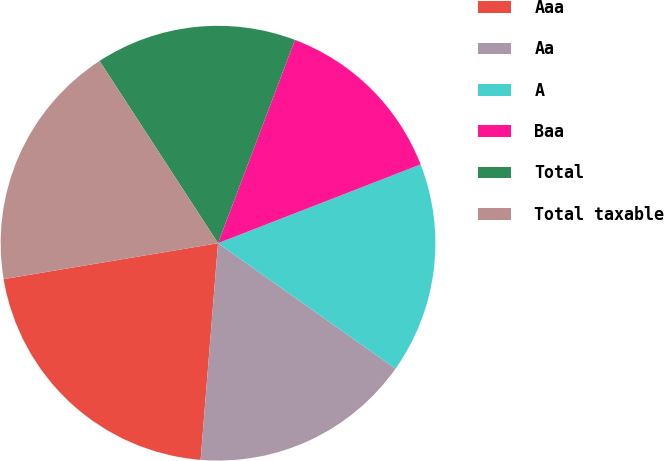<chart> <loc_0><loc_0><loc_500><loc_500><pie_chart><fcel>Aaa<fcel>Aa<fcel>A<fcel>Baa<fcel>Total<fcel>Total taxable<nl><fcel>21.08%<fcel>16.48%<fcel>15.7%<fcel>13.34%<fcel>14.93%<fcel>18.47%<nl></chart> 